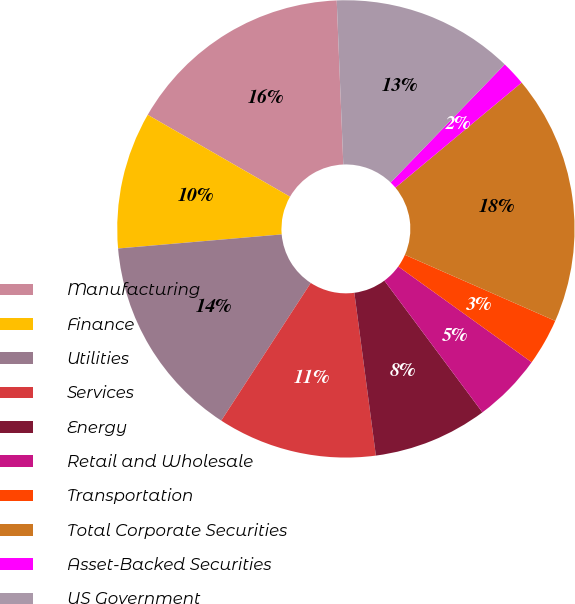Convert chart to OTSL. <chart><loc_0><loc_0><loc_500><loc_500><pie_chart><fcel>Manufacturing<fcel>Finance<fcel>Utilities<fcel>Services<fcel>Energy<fcel>Retail and Wholesale<fcel>Transportation<fcel>Total Corporate Securities<fcel>Asset-Backed Securities<fcel>US Government<nl><fcel>16.05%<fcel>9.68%<fcel>14.46%<fcel>11.27%<fcel>8.09%<fcel>4.91%<fcel>3.32%<fcel>17.64%<fcel>1.73%<fcel>12.86%<nl></chart> 